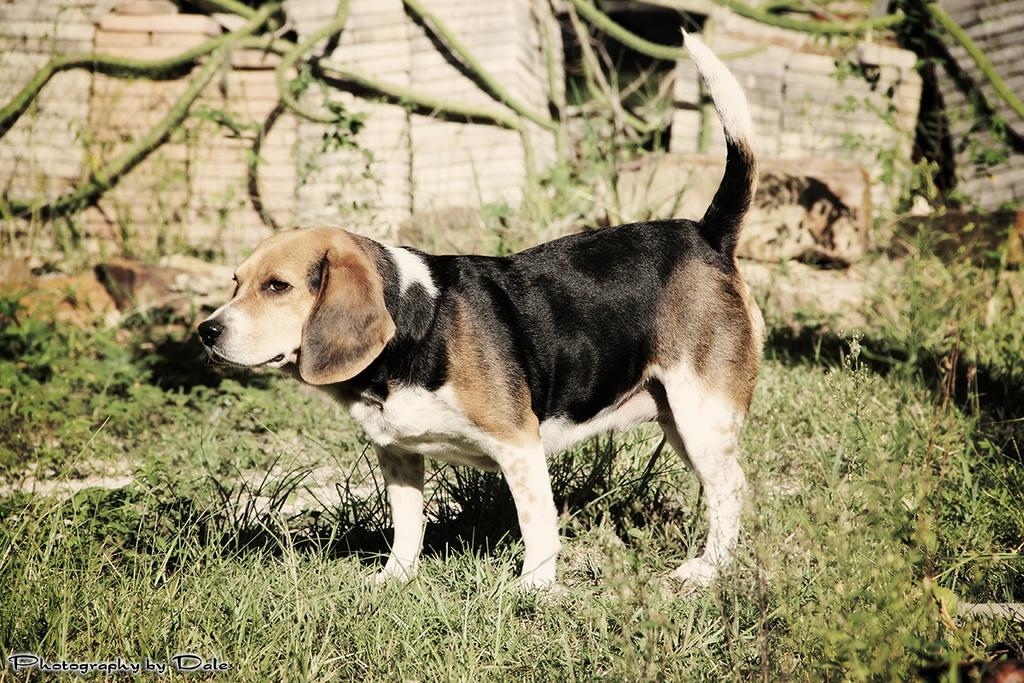What animal can be seen in the image? There is a dog in the image. Where is the dog standing? The dog is standing on a grass path. What is visible behind the dog? There is a wall visible behind the dog. Can you describe any additional features of the image? The image contains a watermark. What type of frame is the dog sitting on in the image? There is no frame present in the image; the dog is standing on a grass path. 